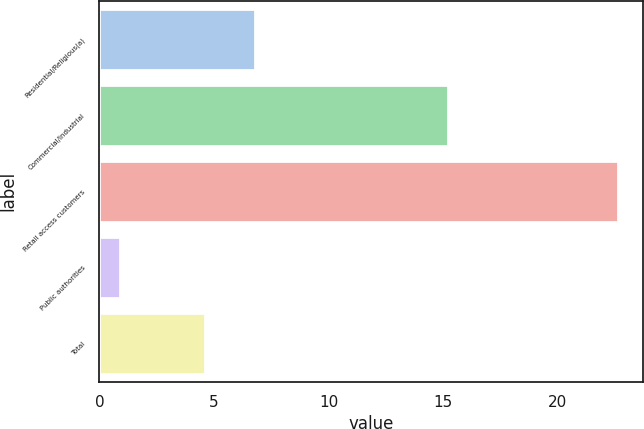Convert chart. <chart><loc_0><loc_0><loc_500><loc_500><bar_chart><fcel>Residential/Religious(a)<fcel>Commercial/Industrial<fcel>Retail access customers<fcel>Public authorities<fcel>Total<nl><fcel>6.77<fcel>15.2<fcel>22.6<fcel>0.9<fcel>4.6<nl></chart> 